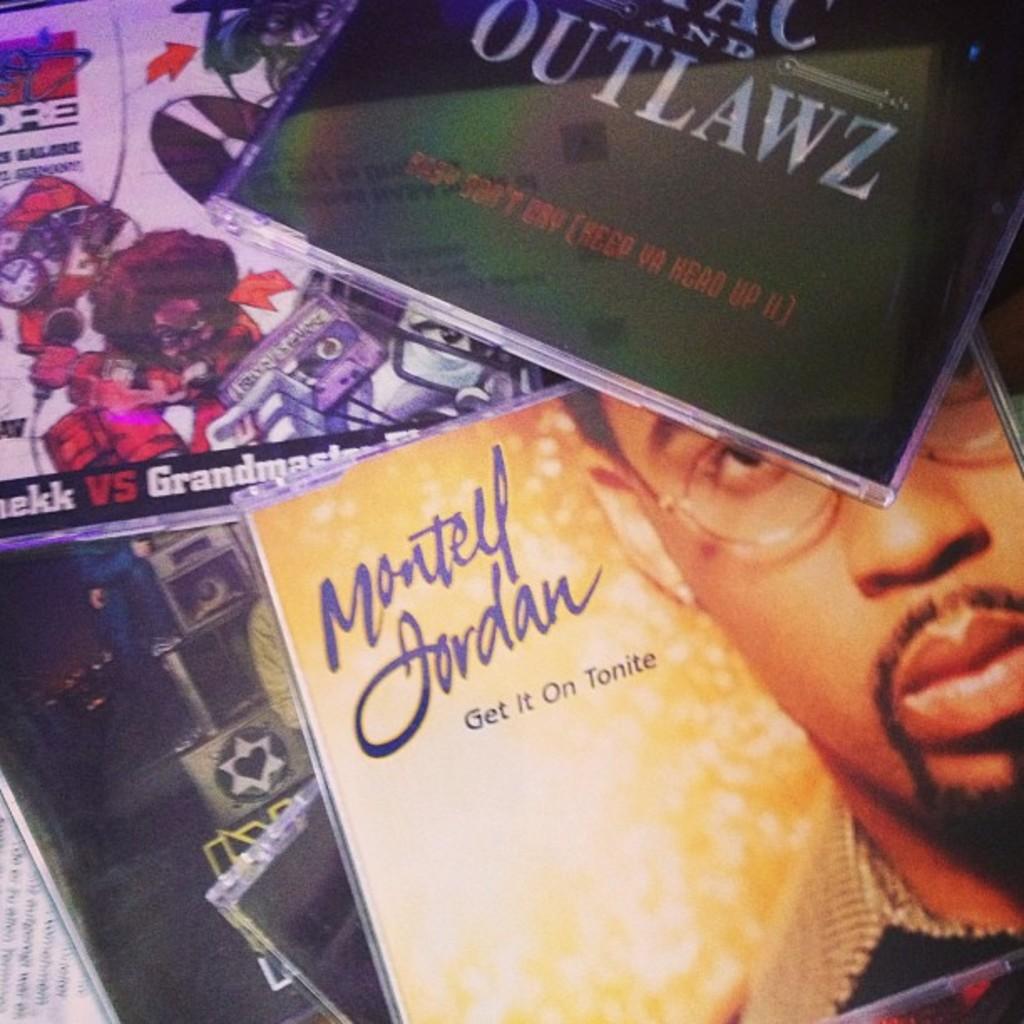Is outlawz written on the case at the top?
Provide a succinct answer. Yes. 